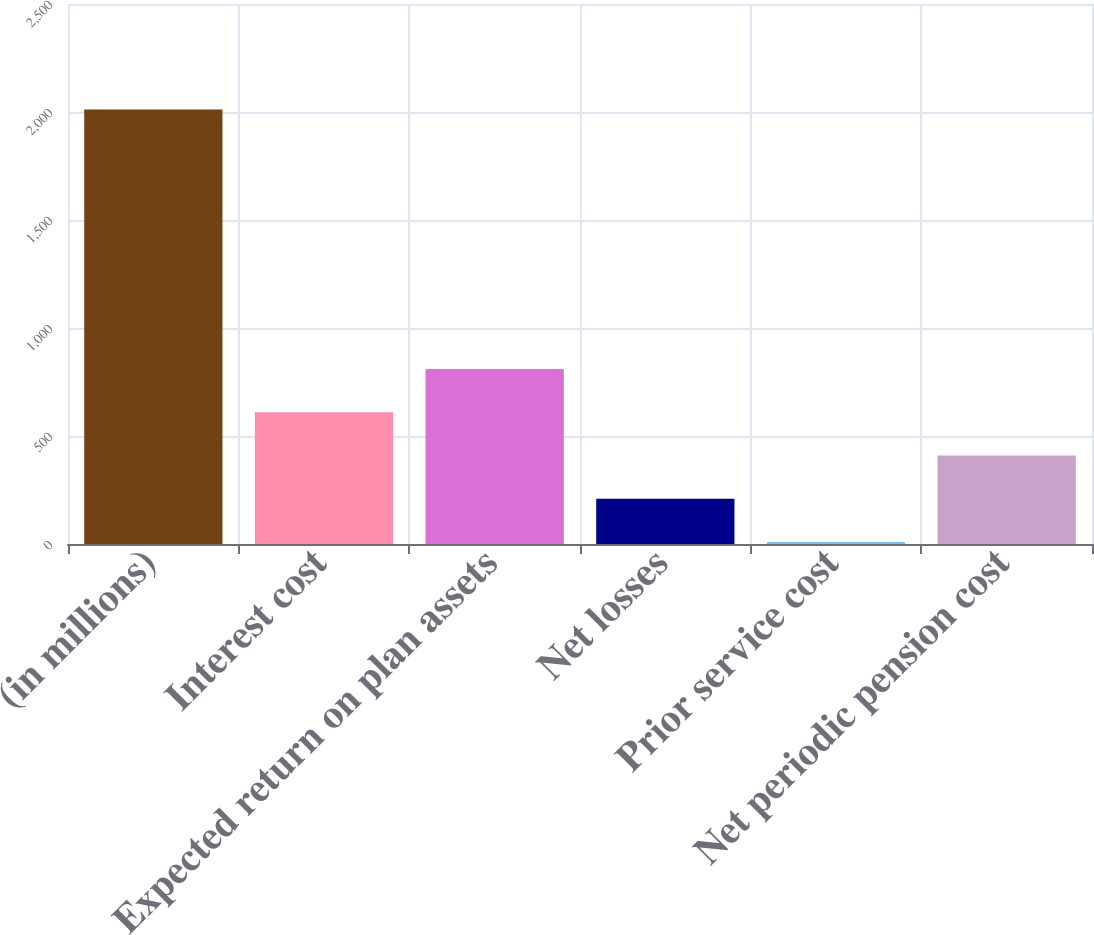Convert chart. <chart><loc_0><loc_0><loc_500><loc_500><bar_chart><fcel>(in millions)<fcel>Interest cost<fcel>Expected return on plan assets<fcel>Net losses<fcel>Prior service cost<fcel>Net periodic pension cost<nl><fcel>2012<fcel>609.9<fcel>810.2<fcel>209.3<fcel>9<fcel>409.6<nl></chart> 